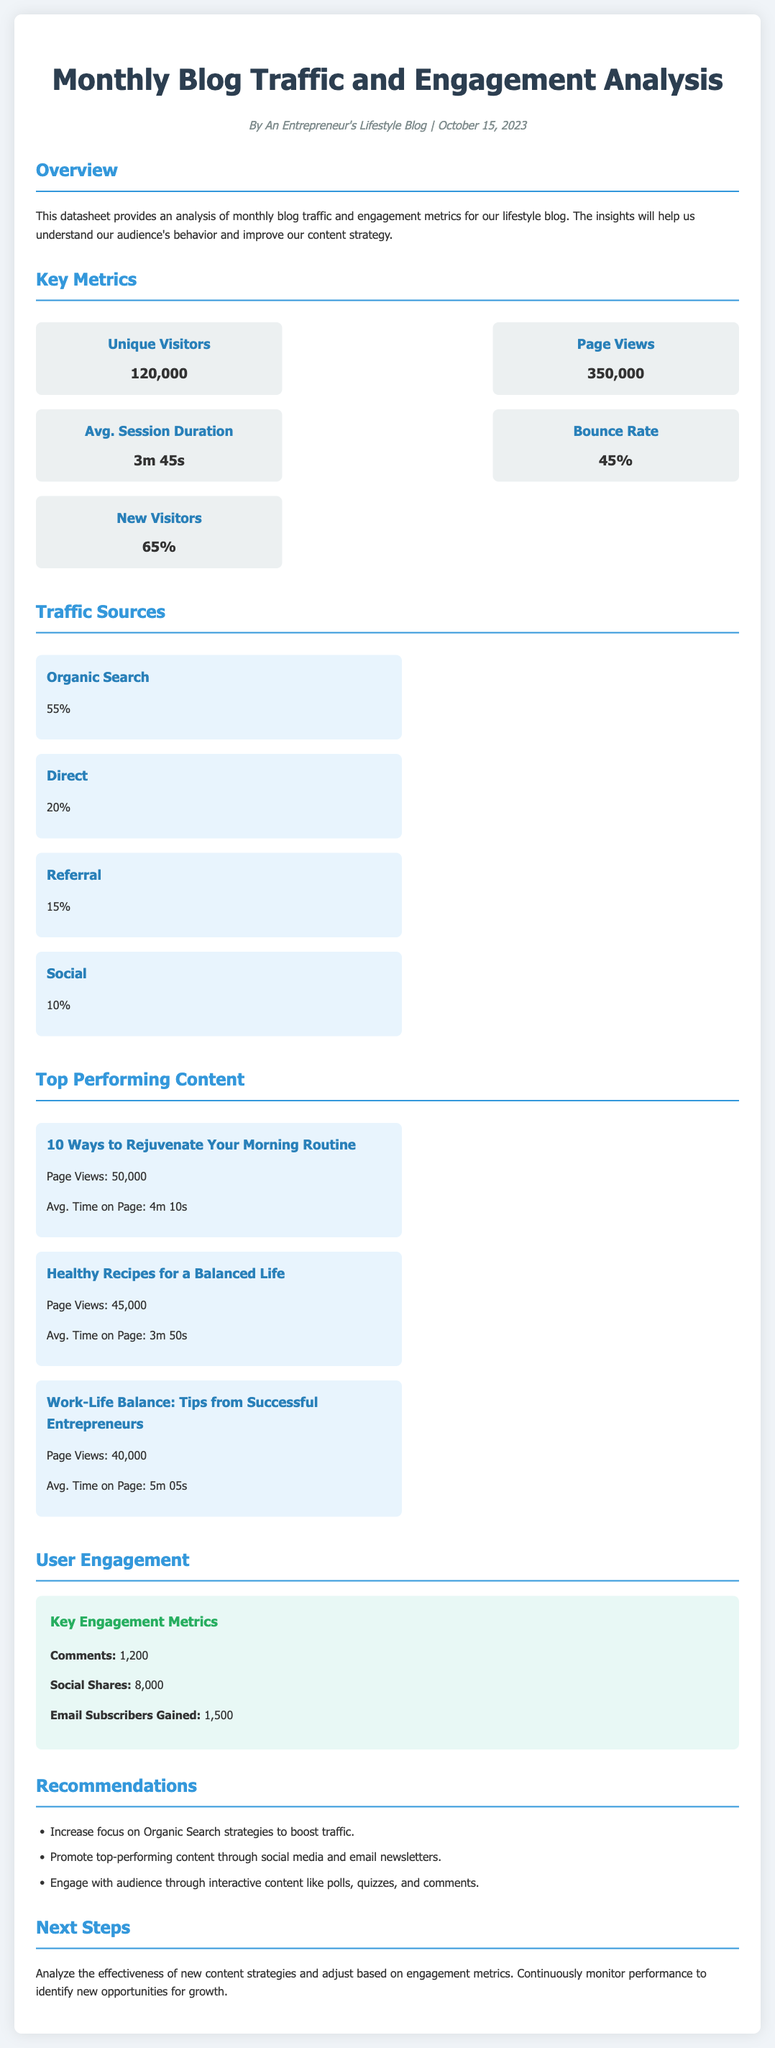What is the unique visitors count? The unique visitors count is specifically mentioned in the key metrics section of the document as 120,000.
Answer: 120,000 What is the average session duration? The average session duration is clearly stated in the key metrics section, which shows it as 3m 45s.
Answer: 3m 45s Which traffic source has the highest percentage? The highest percentage traffic source listed under traffic sources is Organic Search, which is shown as 55%.
Answer: Organic Search How many email subscribers were gained? The number of email subscribers gained is found in the user engagement section and is noted to be 1,500.
Answer: 1,500 What is the total number of comments received? The document specifies that the total number of comments received is 1,200, which is mentioned in the user engagement section.
Answer: 1,200 Which blog post had the highest page views? The blog post with the highest page views is detailed under top performing content and is "10 Ways to Rejuvenate Your Morning Routine" with 50,000 page views.
Answer: 10 Ways to Rejuvenate Your Morning Routine What percentage of visitors are new? The percentage of new visitors is given in the key metrics section as 65%.
Answer: 65% What are the recommendations focused on? The recommendations are elaborated in the recommendations section, focusing on increasing organic search strategies, promoting top content, and engaging with the audience.
Answer: Increasing focus on Organic Search strategies How many social shares were recorded? The social shares recorded is specified in the user engagement section as 8,000.
Answer: 8,000 